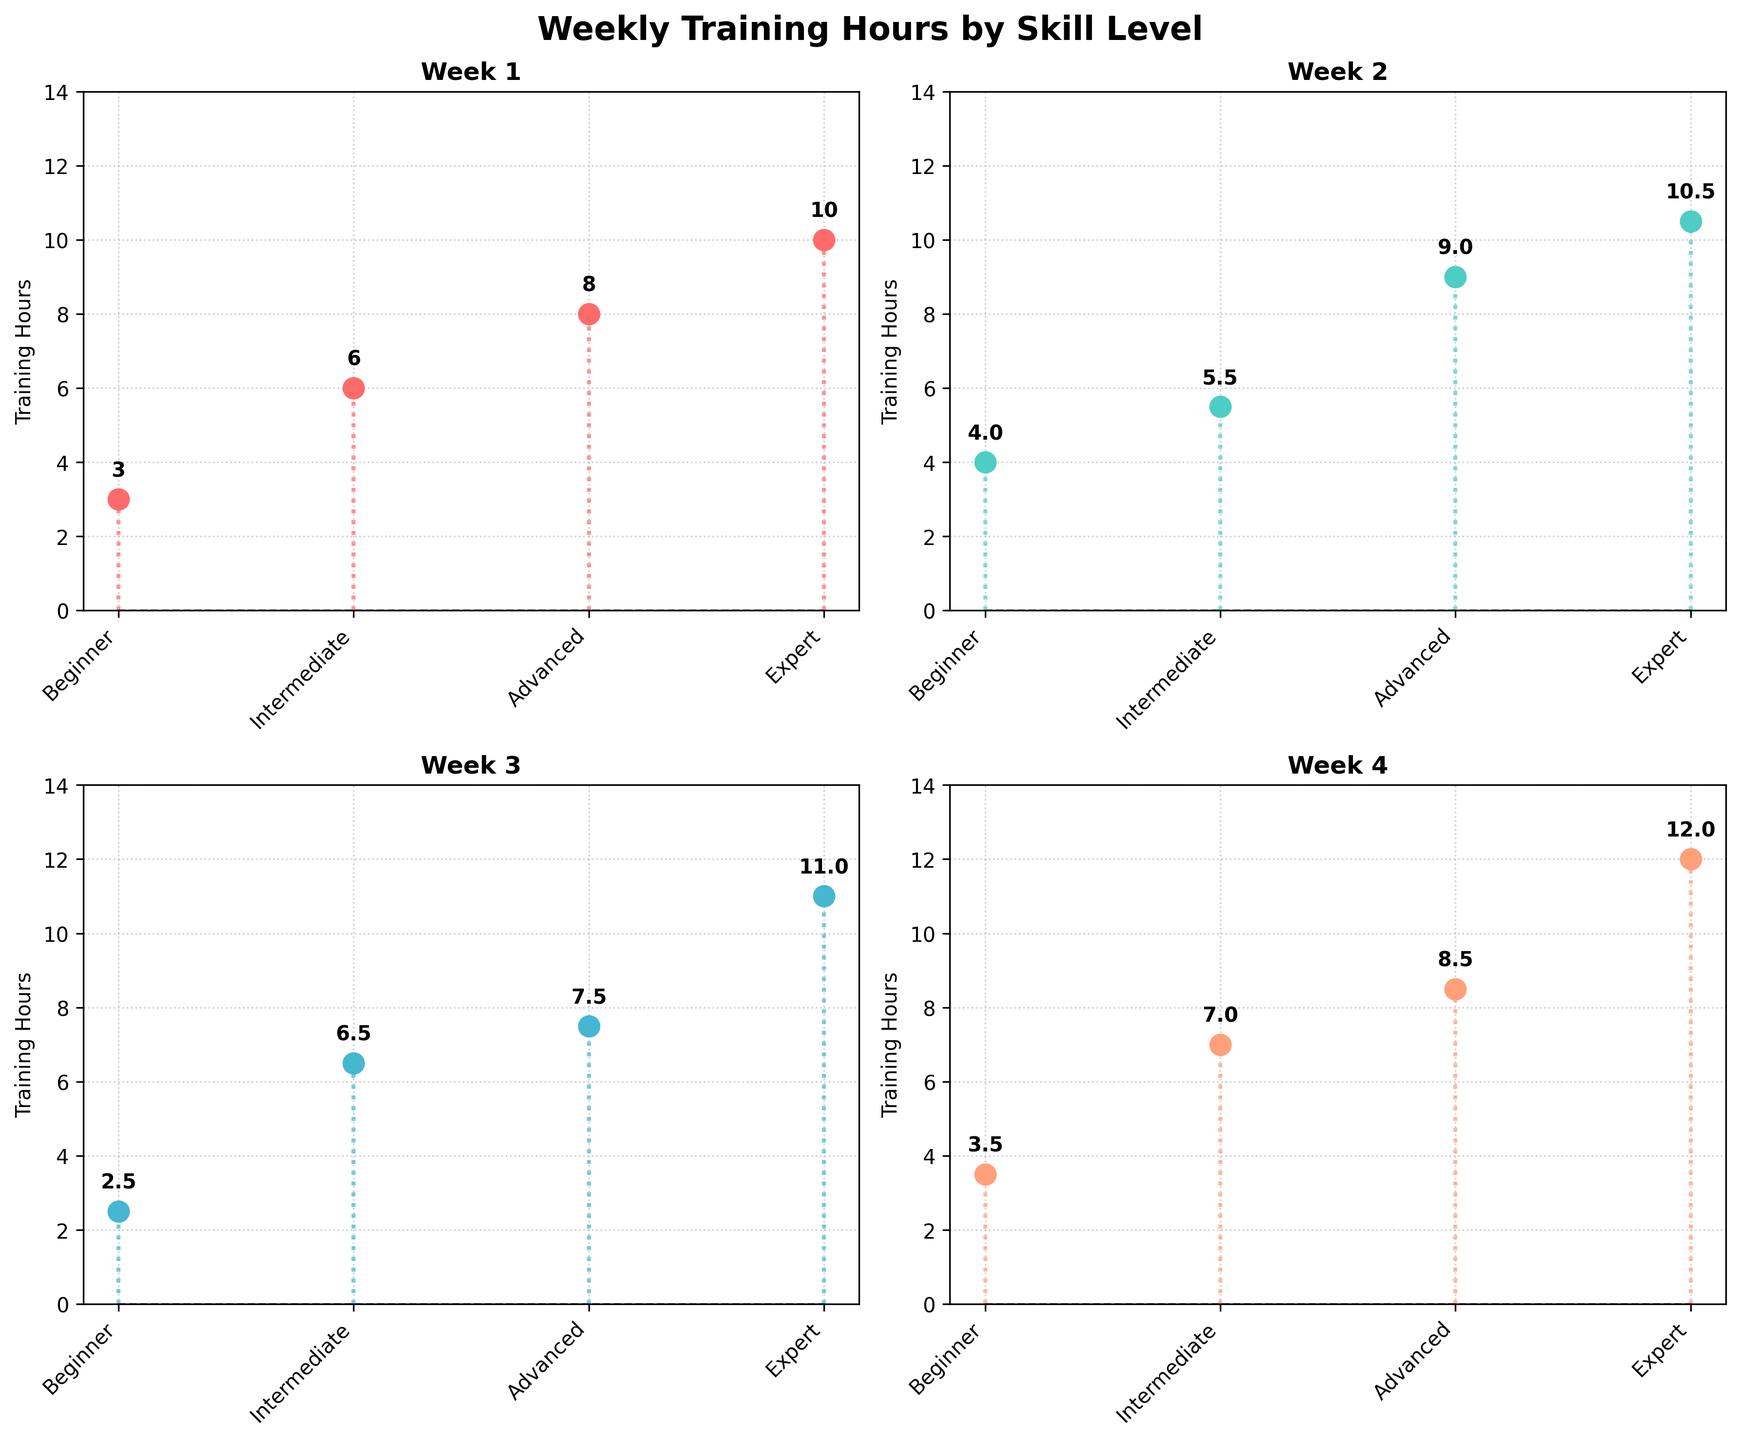What's the title of the figure? The title is typically found at the top of the figure. Here, it clearly states the purpose of the plot.
Answer: Weekly Training Hours by Skill Level How many different skill levels are represented in the plot? Each subplot shows the same four categories on the x-axis, representing the skill levels.
Answer: 4 What color represents the training hours in Week 2? Each subplot uses a different color for the markers, and Week 2 uses a color distinct from the others.
Answer: Teal Which skill level has the highest training hours in Week 1? The first subplot (Week 1) should be examined to see which marker reaches the highest point on the y-axis.
Answer: Expert What's the difference in training hours between the Advanced and Beginner skill levels in Week 4? In the Week 4 subplot, find the training hours for both Advanced and Beginner and subtract the Beginner value from the Advanced value. Advanced: 8.5, Beginner: 3.5. 8.5 - 3.5 = 5
Answer: 5 Which week has the greatest range of training hours across all skill levels? For each week subplot, determine the range by subtracting the smallest value from the largest. Compare across all weeks. Week 4: 12 - 3.5 = 8.5. Week 3: 7.5 - 2.5 = 5. Week 2: 10.5 - 4 = 6.5. Week 1: 10 - 3 = 7
Answer: Week 4 What is the average training hours for Intermediate skill level over all weeks? Sum the training hours for Intermediate across all weeks and divide by the number of weeks. (6 + 5.5 + 6.5 + 7) / 4 = 6.25
Answer: 6.25 Did the Expert skill level increase their training hours each week? Check the training hours for Expert in each week and see if the values continuously increase. Week 1: 10, Week 2: 10.5, Week 3: 11, Week 4: 12
Answer: Yes What is the minimum training hours recorded across all weeks and skill levels? Examine each subplot to find the smallest value present. Weeks: 3 (Beginner, Week 1), 2.5 (Beginner, Week 3). The smallest is 2.5
Answer: 2.5 